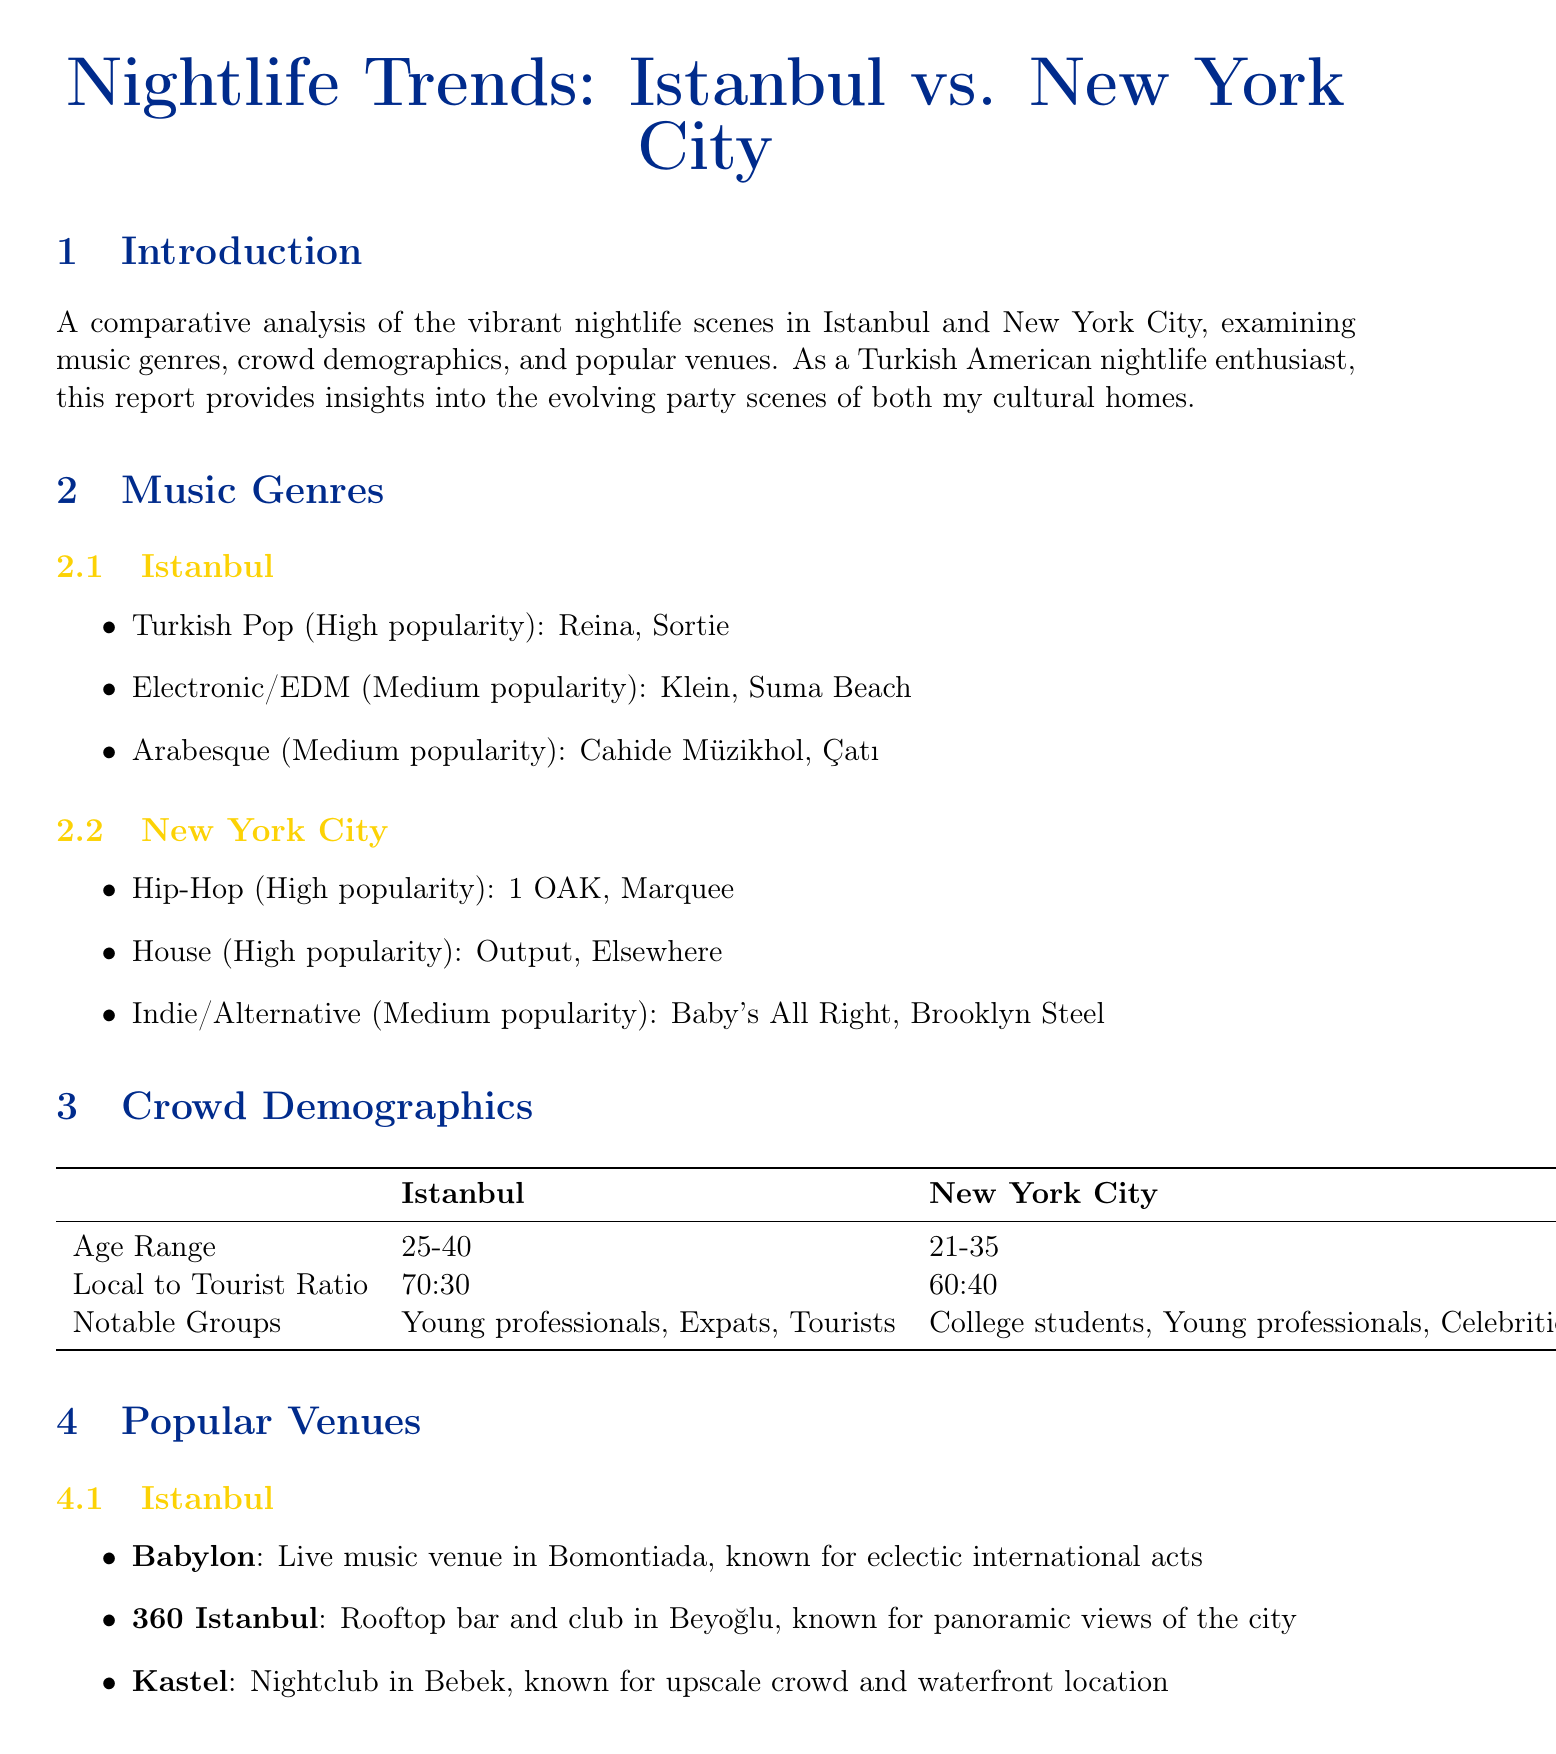What is the age range of the crowd in Istanbul? The document specifies the age range of the crowd in Istanbul as 25-40.
Answer: 25-40 Which genre has high popularity in New York City? According to the report, Hip-Hop and House genres are described as having high popularity in New York City.
Answer: Hip-Hop What is a notable group in the Istanbul nightlife scene? The report lists Young professionals, Expats, and Tourists as notable groups in Istanbul's nightlife scene.
Answer: Young professionals What type of venue is 360 Istanbul? The document describes 360 Istanbul as a rooftop bar and club.
Answer: Rooftop bar and club Which demographic has a higher local to tourist ratio in their nightlife? The local to tourist ratio indicates a higher ratio in Istanbul (70:30) compared to New York (60:40).
Answer: Istanbul What is a common characteristic of New York City's venue styles? The document notes that New York's venues focus on unique concepts and immersive experiences.
Answer: Unique concepts In which district is the House of Yes located? The House of Yes is located in Bushwick, Brooklyn according to the report.
Answer: Bushwick, Brooklyn What genre is medium in popularity in Istanbul? The document states that Electronic/EDM and Arabesque are medium in popularity in Istanbul.
Answer: Electronic/EDM What venue is known for panoramic views of the city? The report mentions that 360 Istanbul is known for panoramic views of the city.
Answer: 360 Istanbul How do crowd behaviors in Istanbul compare to New York? The nightlife crowd in Istanbul tends to start later and party longer compared to New York's stricter closing times.
Answer: Start later and party longer 